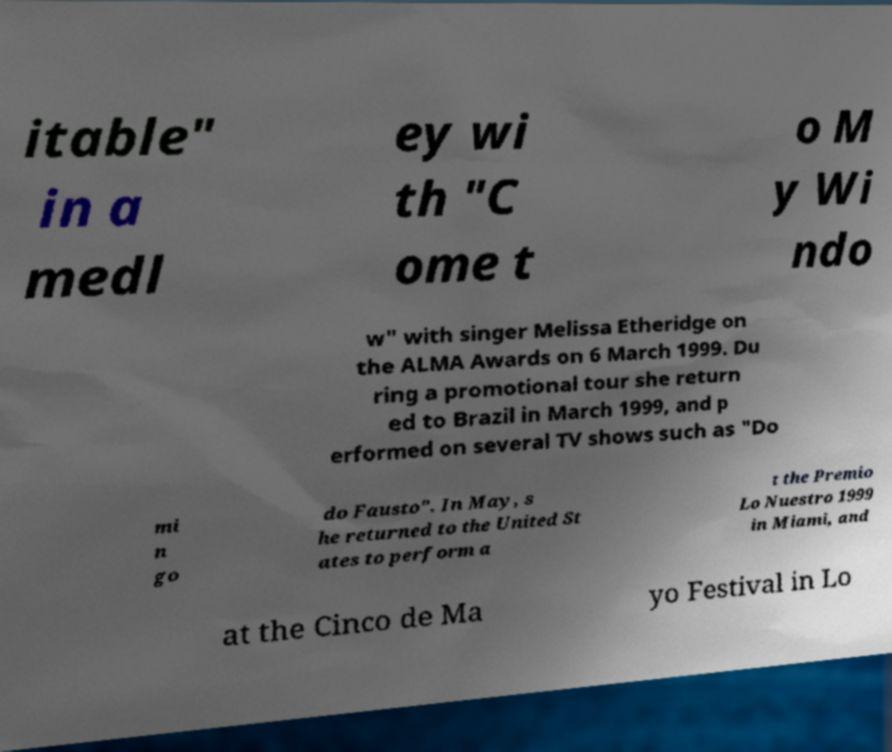Could you extract and type out the text from this image? itable" in a medl ey wi th "C ome t o M y Wi ndo w" with singer Melissa Etheridge on the ALMA Awards on 6 March 1999. Du ring a promotional tour she return ed to Brazil in March 1999, and p erformed on several TV shows such as "Do mi n go do Fausto". In May, s he returned to the United St ates to perform a t the Premio Lo Nuestro 1999 in Miami, and at the Cinco de Ma yo Festival in Lo 